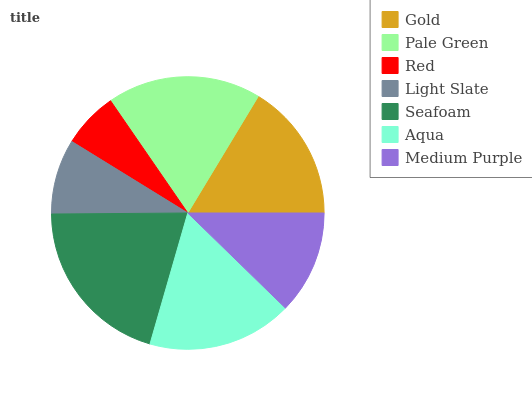Is Red the minimum?
Answer yes or no. Yes. Is Seafoam the maximum?
Answer yes or no. Yes. Is Pale Green the minimum?
Answer yes or no. No. Is Pale Green the maximum?
Answer yes or no. No. Is Pale Green greater than Gold?
Answer yes or no. Yes. Is Gold less than Pale Green?
Answer yes or no. Yes. Is Gold greater than Pale Green?
Answer yes or no. No. Is Pale Green less than Gold?
Answer yes or no. No. Is Gold the high median?
Answer yes or no. Yes. Is Gold the low median?
Answer yes or no. Yes. Is Aqua the high median?
Answer yes or no. No. Is Pale Green the low median?
Answer yes or no. No. 